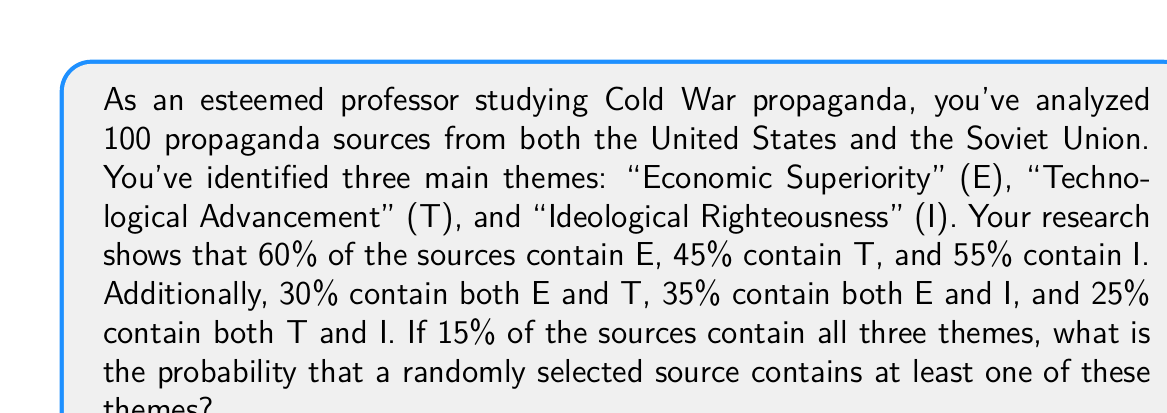Could you help me with this problem? Let's approach this step-by-step using the principle of inclusion-exclusion:

1) Let's define our events:
   E: Source contains "Economic Superiority"
   T: Source contains "Technological Advancement"
   I: Source contains "Ideological Righteousness"

2) We're given:
   P(E) = 0.60, P(T) = 0.45, P(I) = 0.55
   P(E ∩ T) = 0.30, P(E ∩ I) = 0.35, P(T ∩ I) = 0.25
   P(E ∩ T ∩ I) = 0.15

3) We need to find P(E ∪ T ∪ I). The formula is:

   $$P(E ∪ T ∪ I) = P(E) + P(T) + P(I) - P(E ∩ T) - P(E ∩ I) - P(T ∩ I) + P(E ∩ T ∩ I)$$

4) Substituting the values:

   $$P(E ∪ T ∪ I) = 0.60 + 0.45 + 0.55 - 0.30 - 0.35 - 0.25 + 0.15$$

5) Calculating:

   $$P(E ∪ T ∪ I) = 1.60 - 0.90 + 0.15 = 0.85$$

Therefore, the probability that a randomly selected source contains at least one of these themes is 0.85 or 85%.
Answer: 0.85 